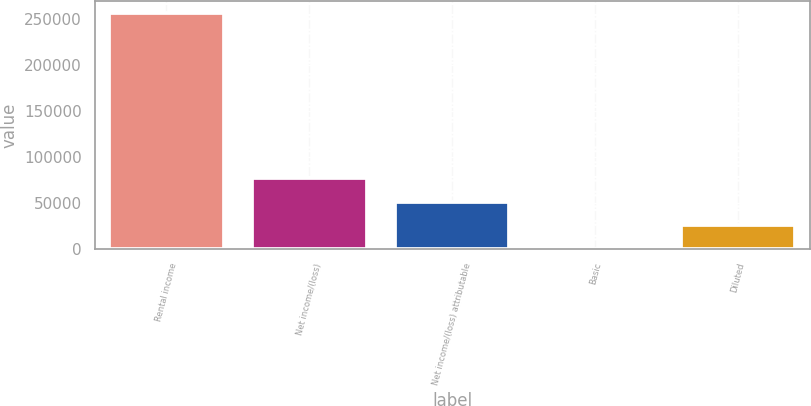<chart> <loc_0><loc_0><loc_500><loc_500><bar_chart><fcel>Rental income<fcel>Net income/(loss)<fcel>Net income/(loss) attributable<fcel>Basic<fcel>Diluted<nl><fcel>256634<fcel>76990.2<fcel>51326.8<fcel>0.07<fcel>25663.5<nl></chart> 